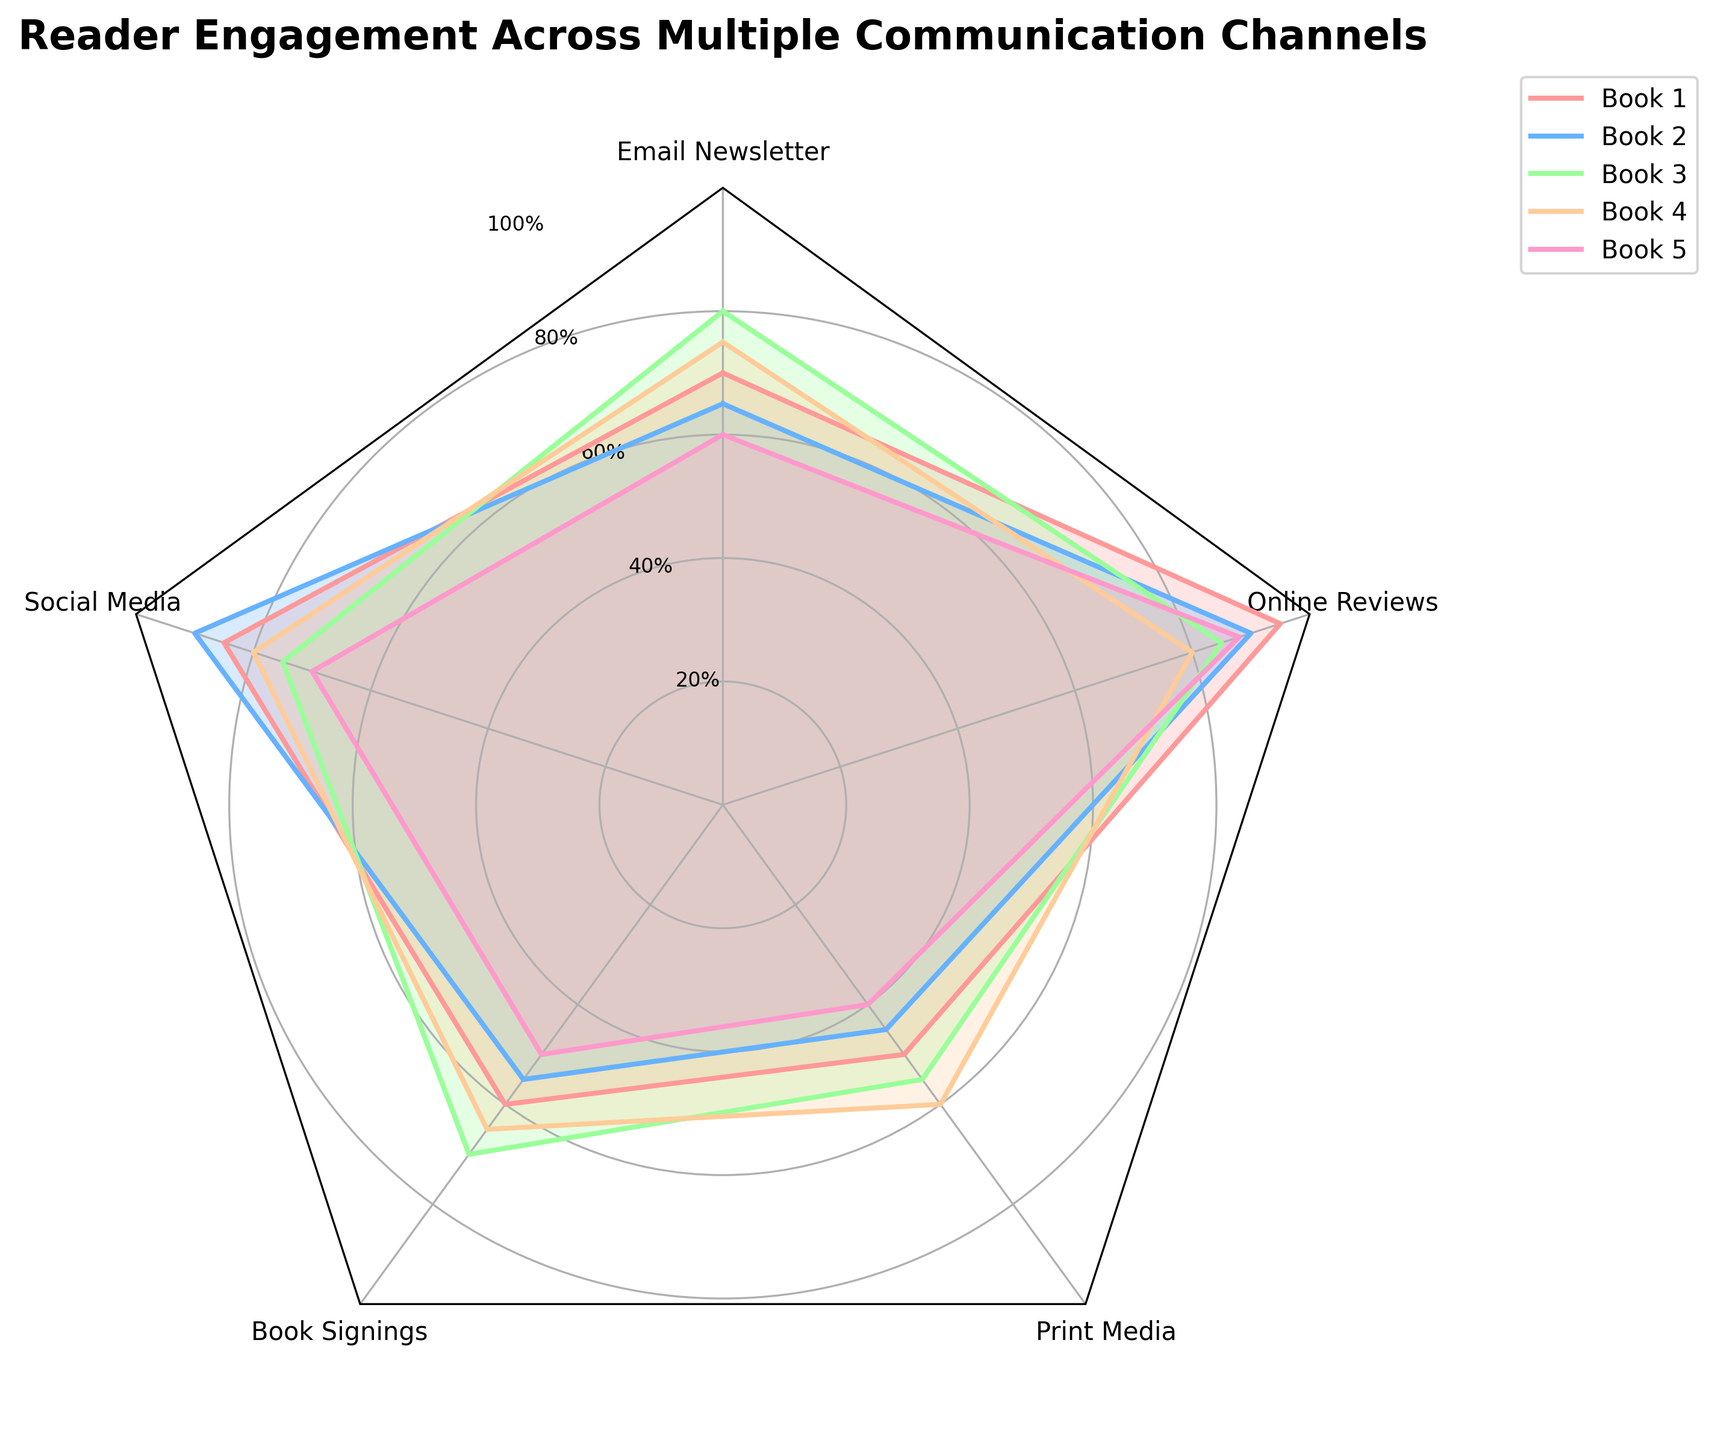What is the title of the radar chart? The title is located at the top of the radar chart. The words "Reader Engagement Across Multiple Communication Channels" are written in bold and are placed above the chart.
Answer: Reader Engagement Across Multiple Communication Channels Which book has the highest reader engagement through Social Media? By looking at the radar chart where the Social Media axis is located, we can see that Book 2 has the highest value in that segment.
Answer: Book 2 What is the range of values on the y-axis? The y-axis of the radar chart is the circular axis that goes from the center to the outer edge. It is marked in increments of 20, ranging from 20% to 100%.
Answer: 20% to 100% Which communication channel shows the least reader engagement for Book 5? By examining the radar chart for Book 5, we can identify that Book Signings has the lowest value in the chart for that book.
Answer: Book Signings On which channel does Book 3 perform better than Book 4? Looking at the radar chart and comparing the segments for Book 3 and Book 4, we see that Book 3 performs better than Book 4 in Online Reviews.
Answer: Online Reviews Which communication channel has the most consistent reader engagement across all books? Consistent engagement means values are close together for all books. The importance of Online Reviews shows more clustered scores across the board compared to other channels.
Answer: Online Reviews What is the average engagement for Book 1 across all channels? Adding the engagement values for Book 1 (70, 85, 60, 50, 95) and then dividing by the number of channels (5) gives the average: (70 + 85 + 60 + 50 + 95) / 5 = 72
Answer: 72 How does the engagement in Print Media for Book 2 compare to Book 4? By examining the Print Media segment for both books, we see that Book 4 (60) has a higher engagement than Book 2 (45).
Answer: Book 4 has higher engagement What communication channel has the lowest overall reader engagement? By examining the radar chart, we look across all channels and compare the lowest values. Print Media has the overall lowest engagement, especially in Book 5.
Answer: Print Media Which book has the most balanced reader engagement across all channels? The most balanced indicates similar values across all channels. By looking at the radar chart, Book 4 has relatively balanced scores across all segments compared to other books.
Answer: Book 4 